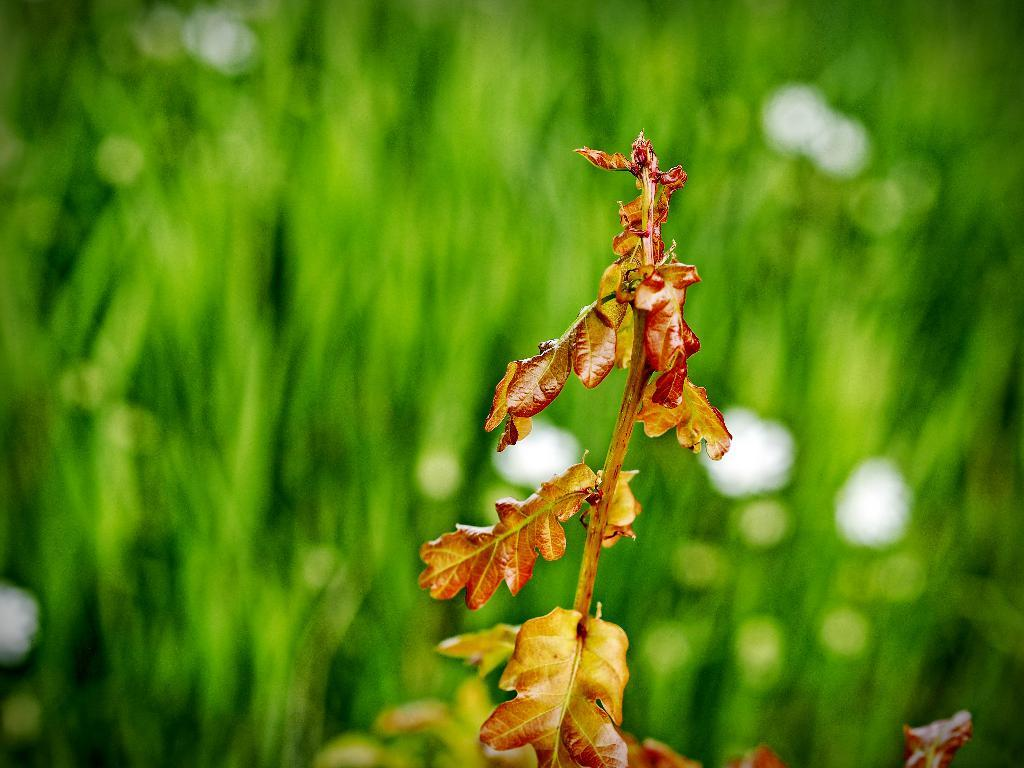What type of tree is featured in the image? There is a tree with orange-colored leaves in the image. What can be seen in the background of the image? There are green trees in the background of the image. What type of hall is visible in the image? There is no hall present in the image; it features a tree with orange-colored leaves and green trees in the background. 